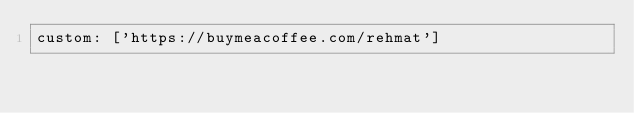Convert code to text. <code><loc_0><loc_0><loc_500><loc_500><_YAML_>custom: ['https://buymeacoffee.com/rehmat']</code> 